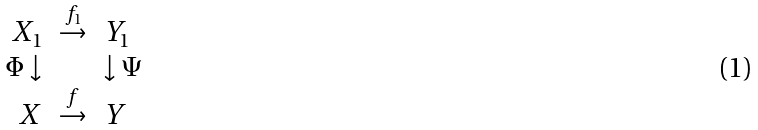Convert formula to latex. <formula><loc_0><loc_0><loc_500><loc_500>\begin{array} { r c l } X _ { 1 } & \stackrel { f _ { 1 } } { \rightarrow } & Y _ { 1 } \\ \Phi \downarrow & & \downarrow \Psi \\ X & \stackrel { f } { \rightarrow } & Y \end{array}</formula> 